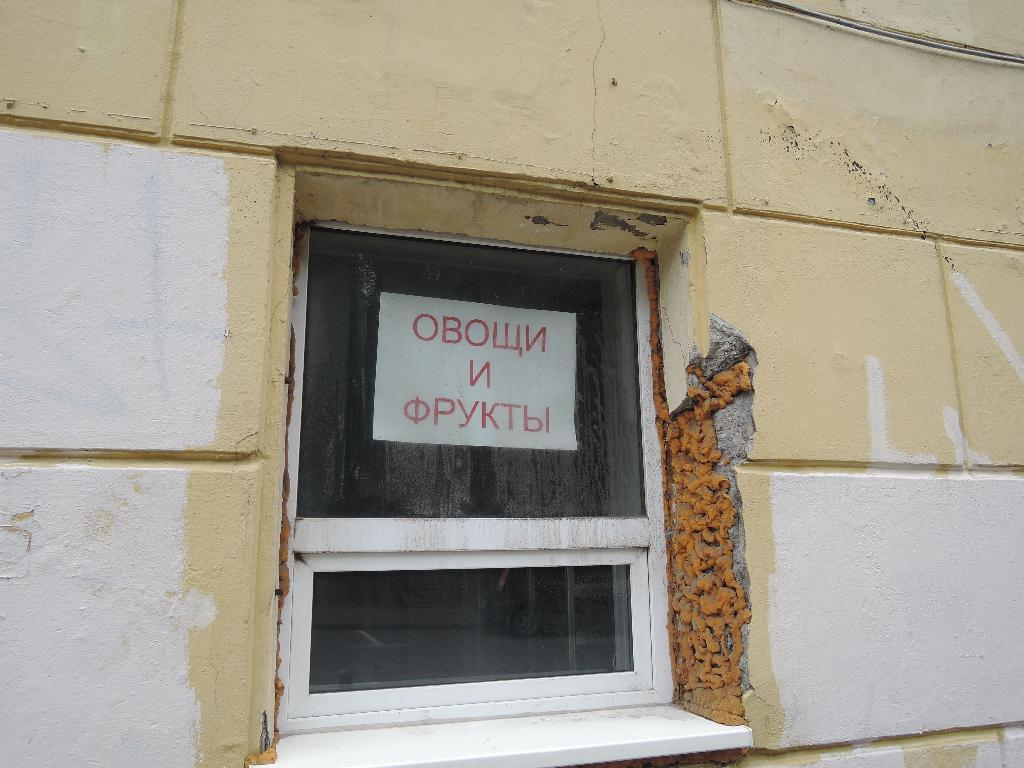What can be seen on the glass in the image? There is a poster on the window glass in the image. What is located near the window? There is a wall in the image. How many boats are visible in the image? There are no boats present in the image. What type of humor can be seen in the poster on the window glass? The poster's content cannot be determined from the image, so it's not possible to determine if it contains humor. 